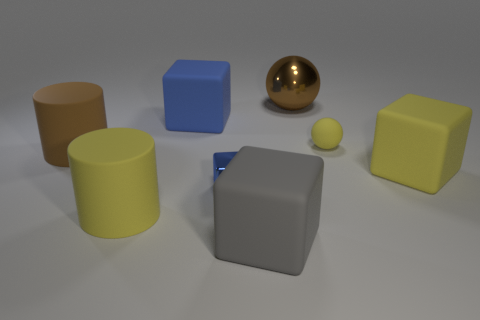How many blue things are small rubber spheres or tiny blocks?
Make the answer very short. 1. There is a small yellow object; what shape is it?
Provide a succinct answer. Sphere. How many other objects are there of the same shape as the large gray rubber thing?
Offer a terse response. 3. What is the color of the big rubber cube that is on the left side of the gray rubber thing?
Offer a very short reply. Blue. Do the small yellow object and the yellow cylinder have the same material?
Ensure brevity in your answer.  Yes. What number of objects are rubber balls or things that are on the right side of the large gray rubber cube?
Offer a terse response. 3. There is a brown thing to the left of the gray object; what shape is it?
Offer a terse response. Cylinder. There is a big matte cube to the right of the brown shiny sphere; is it the same color as the tiny ball?
Give a very brief answer. Yes. What is the material of the big cube that is the same color as the small shiny block?
Keep it short and to the point. Rubber. Is the size of the brown object behind the yellow sphere the same as the metallic cube?
Keep it short and to the point. No. 